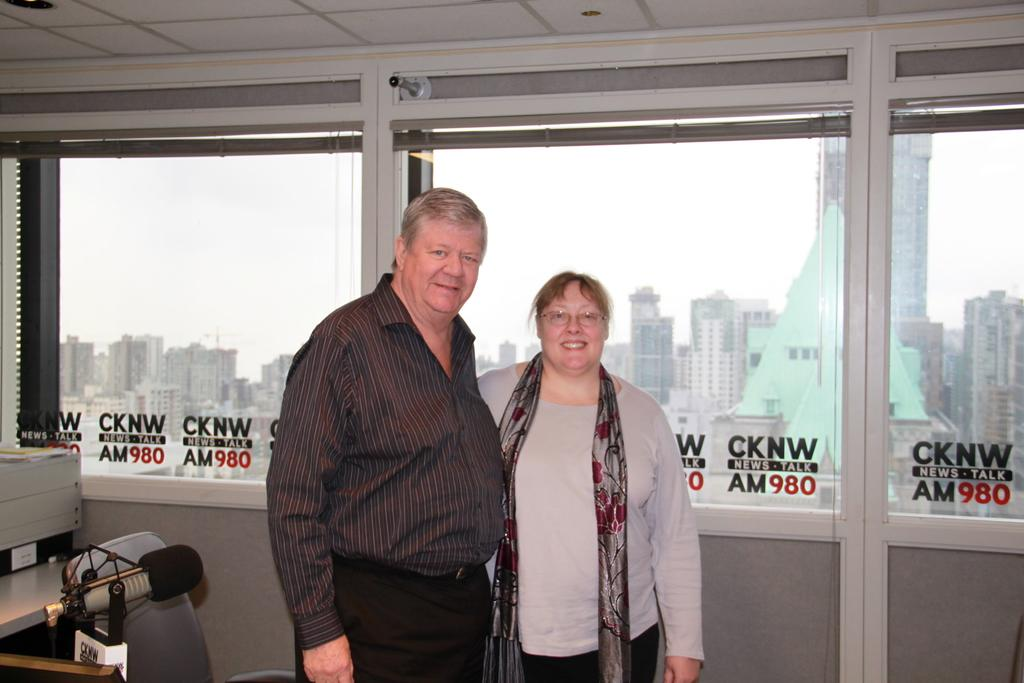How many people are in the image? There are two people in the image, a man and a woman. What are the man and woman doing in the image? The man and woman are standing together and smiling. What can be seen through the glass window in the image? Buildings and the sky are visible through the glass window. What type of glue is being used by the man and woman in the image? There is no glue present in the image; the man and woman are simply standing together and smiling. 